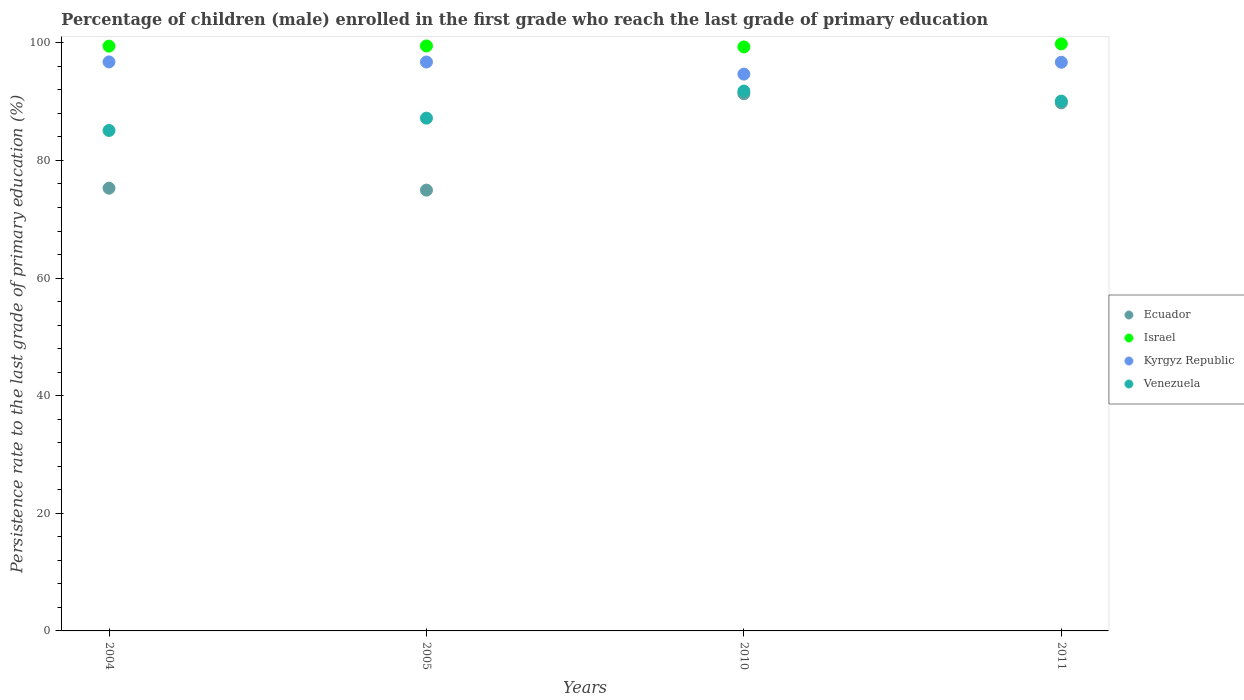How many different coloured dotlines are there?
Make the answer very short. 4. What is the persistence rate of children in Venezuela in 2010?
Give a very brief answer. 91.8. Across all years, what is the maximum persistence rate of children in Ecuador?
Provide a succinct answer. 91.34. Across all years, what is the minimum persistence rate of children in Ecuador?
Ensure brevity in your answer.  74.95. What is the total persistence rate of children in Venezuela in the graph?
Your answer should be very brief. 354.17. What is the difference between the persistence rate of children in Kyrgyz Republic in 2004 and that in 2011?
Your answer should be very brief. 0.06. What is the difference between the persistence rate of children in Israel in 2005 and the persistence rate of children in Kyrgyz Republic in 2010?
Your answer should be compact. 4.79. What is the average persistence rate of children in Israel per year?
Make the answer very short. 99.51. In the year 2011, what is the difference between the persistence rate of children in Ecuador and persistence rate of children in Israel?
Your answer should be compact. -10.03. In how many years, is the persistence rate of children in Ecuador greater than 64 %?
Your answer should be compact. 4. What is the ratio of the persistence rate of children in Kyrgyz Republic in 2005 to that in 2011?
Provide a succinct answer. 1. Is the persistence rate of children in Ecuador in 2004 less than that in 2011?
Keep it short and to the point. Yes. Is the difference between the persistence rate of children in Ecuador in 2004 and 2011 greater than the difference between the persistence rate of children in Israel in 2004 and 2011?
Provide a short and direct response. No. What is the difference between the highest and the second highest persistence rate of children in Venezuela?
Provide a short and direct response. 1.71. What is the difference between the highest and the lowest persistence rate of children in Venezuela?
Make the answer very short. 6.7. Is it the case that in every year, the sum of the persistence rate of children in Kyrgyz Republic and persistence rate of children in Israel  is greater than the persistence rate of children in Ecuador?
Your response must be concise. Yes. Does the persistence rate of children in Israel monotonically increase over the years?
Your response must be concise. No. Is the persistence rate of children in Israel strictly greater than the persistence rate of children in Kyrgyz Republic over the years?
Offer a very short reply. Yes. How many years are there in the graph?
Offer a terse response. 4. What is the difference between two consecutive major ticks on the Y-axis?
Ensure brevity in your answer.  20. Where does the legend appear in the graph?
Offer a terse response. Center right. How many legend labels are there?
Give a very brief answer. 4. How are the legend labels stacked?
Your response must be concise. Vertical. What is the title of the graph?
Make the answer very short. Percentage of children (male) enrolled in the first grade who reach the last grade of primary education. Does "Panama" appear as one of the legend labels in the graph?
Your response must be concise. No. What is the label or title of the Y-axis?
Your answer should be compact. Persistence rate to the last grade of primary education (%). What is the Persistence rate to the last grade of primary education (%) of Ecuador in 2004?
Offer a terse response. 75.28. What is the Persistence rate to the last grade of primary education (%) in Israel in 2004?
Offer a terse response. 99.44. What is the Persistence rate to the last grade of primary education (%) in Kyrgyz Republic in 2004?
Offer a very short reply. 96.75. What is the Persistence rate to the last grade of primary education (%) of Venezuela in 2004?
Make the answer very short. 85.1. What is the Persistence rate to the last grade of primary education (%) in Ecuador in 2005?
Ensure brevity in your answer.  74.95. What is the Persistence rate to the last grade of primary education (%) of Israel in 2005?
Your response must be concise. 99.47. What is the Persistence rate to the last grade of primary education (%) in Kyrgyz Republic in 2005?
Offer a very short reply. 96.74. What is the Persistence rate to the last grade of primary education (%) of Venezuela in 2005?
Ensure brevity in your answer.  87.19. What is the Persistence rate to the last grade of primary education (%) in Ecuador in 2010?
Offer a terse response. 91.34. What is the Persistence rate to the last grade of primary education (%) of Israel in 2010?
Provide a succinct answer. 99.3. What is the Persistence rate to the last grade of primary education (%) in Kyrgyz Republic in 2010?
Give a very brief answer. 94.68. What is the Persistence rate to the last grade of primary education (%) in Venezuela in 2010?
Ensure brevity in your answer.  91.8. What is the Persistence rate to the last grade of primary education (%) in Ecuador in 2011?
Your answer should be very brief. 89.79. What is the Persistence rate to the last grade of primary education (%) of Israel in 2011?
Give a very brief answer. 99.82. What is the Persistence rate to the last grade of primary education (%) of Kyrgyz Republic in 2011?
Give a very brief answer. 96.7. What is the Persistence rate to the last grade of primary education (%) of Venezuela in 2011?
Make the answer very short. 90.09. Across all years, what is the maximum Persistence rate to the last grade of primary education (%) of Ecuador?
Give a very brief answer. 91.34. Across all years, what is the maximum Persistence rate to the last grade of primary education (%) in Israel?
Your answer should be compact. 99.82. Across all years, what is the maximum Persistence rate to the last grade of primary education (%) in Kyrgyz Republic?
Make the answer very short. 96.75. Across all years, what is the maximum Persistence rate to the last grade of primary education (%) of Venezuela?
Your answer should be very brief. 91.8. Across all years, what is the minimum Persistence rate to the last grade of primary education (%) of Ecuador?
Your answer should be very brief. 74.95. Across all years, what is the minimum Persistence rate to the last grade of primary education (%) in Israel?
Offer a terse response. 99.3. Across all years, what is the minimum Persistence rate to the last grade of primary education (%) in Kyrgyz Republic?
Your answer should be compact. 94.68. Across all years, what is the minimum Persistence rate to the last grade of primary education (%) of Venezuela?
Your response must be concise. 85.1. What is the total Persistence rate to the last grade of primary education (%) of Ecuador in the graph?
Give a very brief answer. 331.36. What is the total Persistence rate to the last grade of primary education (%) of Israel in the graph?
Ensure brevity in your answer.  398.02. What is the total Persistence rate to the last grade of primary education (%) of Kyrgyz Republic in the graph?
Your answer should be very brief. 384.87. What is the total Persistence rate to the last grade of primary education (%) of Venezuela in the graph?
Your answer should be very brief. 354.17. What is the difference between the Persistence rate to the last grade of primary education (%) of Ecuador in 2004 and that in 2005?
Offer a very short reply. 0.33. What is the difference between the Persistence rate to the last grade of primary education (%) in Israel in 2004 and that in 2005?
Give a very brief answer. -0.03. What is the difference between the Persistence rate to the last grade of primary education (%) in Kyrgyz Republic in 2004 and that in 2005?
Give a very brief answer. 0.02. What is the difference between the Persistence rate to the last grade of primary education (%) of Venezuela in 2004 and that in 2005?
Provide a short and direct response. -2.1. What is the difference between the Persistence rate to the last grade of primary education (%) of Ecuador in 2004 and that in 2010?
Your answer should be very brief. -16.06. What is the difference between the Persistence rate to the last grade of primary education (%) in Israel in 2004 and that in 2010?
Provide a succinct answer. 0.14. What is the difference between the Persistence rate to the last grade of primary education (%) of Kyrgyz Republic in 2004 and that in 2010?
Offer a terse response. 2.07. What is the difference between the Persistence rate to the last grade of primary education (%) in Venezuela in 2004 and that in 2010?
Provide a short and direct response. -6.7. What is the difference between the Persistence rate to the last grade of primary education (%) in Ecuador in 2004 and that in 2011?
Provide a short and direct response. -14.51. What is the difference between the Persistence rate to the last grade of primary education (%) of Israel in 2004 and that in 2011?
Offer a very short reply. -0.38. What is the difference between the Persistence rate to the last grade of primary education (%) in Kyrgyz Republic in 2004 and that in 2011?
Make the answer very short. 0.06. What is the difference between the Persistence rate to the last grade of primary education (%) in Venezuela in 2004 and that in 2011?
Give a very brief answer. -4.99. What is the difference between the Persistence rate to the last grade of primary education (%) in Ecuador in 2005 and that in 2010?
Give a very brief answer. -16.39. What is the difference between the Persistence rate to the last grade of primary education (%) in Israel in 2005 and that in 2010?
Offer a very short reply. 0.17. What is the difference between the Persistence rate to the last grade of primary education (%) in Kyrgyz Republic in 2005 and that in 2010?
Provide a short and direct response. 2.06. What is the difference between the Persistence rate to the last grade of primary education (%) in Venezuela in 2005 and that in 2010?
Ensure brevity in your answer.  -4.6. What is the difference between the Persistence rate to the last grade of primary education (%) in Ecuador in 2005 and that in 2011?
Provide a succinct answer. -14.84. What is the difference between the Persistence rate to the last grade of primary education (%) of Israel in 2005 and that in 2011?
Provide a short and direct response. -0.35. What is the difference between the Persistence rate to the last grade of primary education (%) in Kyrgyz Republic in 2005 and that in 2011?
Make the answer very short. 0.04. What is the difference between the Persistence rate to the last grade of primary education (%) of Venezuela in 2005 and that in 2011?
Keep it short and to the point. -2.9. What is the difference between the Persistence rate to the last grade of primary education (%) of Ecuador in 2010 and that in 2011?
Provide a short and direct response. 1.55. What is the difference between the Persistence rate to the last grade of primary education (%) of Israel in 2010 and that in 2011?
Provide a succinct answer. -0.52. What is the difference between the Persistence rate to the last grade of primary education (%) of Kyrgyz Republic in 2010 and that in 2011?
Give a very brief answer. -2.02. What is the difference between the Persistence rate to the last grade of primary education (%) in Venezuela in 2010 and that in 2011?
Offer a terse response. 1.71. What is the difference between the Persistence rate to the last grade of primary education (%) in Ecuador in 2004 and the Persistence rate to the last grade of primary education (%) in Israel in 2005?
Provide a succinct answer. -24.19. What is the difference between the Persistence rate to the last grade of primary education (%) of Ecuador in 2004 and the Persistence rate to the last grade of primary education (%) of Kyrgyz Republic in 2005?
Keep it short and to the point. -21.46. What is the difference between the Persistence rate to the last grade of primary education (%) in Ecuador in 2004 and the Persistence rate to the last grade of primary education (%) in Venezuela in 2005?
Provide a succinct answer. -11.91. What is the difference between the Persistence rate to the last grade of primary education (%) of Israel in 2004 and the Persistence rate to the last grade of primary education (%) of Kyrgyz Republic in 2005?
Your answer should be compact. 2.7. What is the difference between the Persistence rate to the last grade of primary education (%) in Israel in 2004 and the Persistence rate to the last grade of primary education (%) in Venezuela in 2005?
Your response must be concise. 12.24. What is the difference between the Persistence rate to the last grade of primary education (%) in Kyrgyz Republic in 2004 and the Persistence rate to the last grade of primary education (%) in Venezuela in 2005?
Your answer should be compact. 9.56. What is the difference between the Persistence rate to the last grade of primary education (%) of Ecuador in 2004 and the Persistence rate to the last grade of primary education (%) of Israel in 2010?
Your response must be concise. -24.02. What is the difference between the Persistence rate to the last grade of primary education (%) in Ecuador in 2004 and the Persistence rate to the last grade of primary education (%) in Kyrgyz Republic in 2010?
Make the answer very short. -19.4. What is the difference between the Persistence rate to the last grade of primary education (%) of Ecuador in 2004 and the Persistence rate to the last grade of primary education (%) of Venezuela in 2010?
Your answer should be very brief. -16.52. What is the difference between the Persistence rate to the last grade of primary education (%) of Israel in 2004 and the Persistence rate to the last grade of primary education (%) of Kyrgyz Republic in 2010?
Keep it short and to the point. 4.76. What is the difference between the Persistence rate to the last grade of primary education (%) of Israel in 2004 and the Persistence rate to the last grade of primary education (%) of Venezuela in 2010?
Ensure brevity in your answer.  7.64. What is the difference between the Persistence rate to the last grade of primary education (%) in Kyrgyz Republic in 2004 and the Persistence rate to the last grade of primary education (%) in Venezuela in 2010?
Provide a succinct answer. 4.96. What is the difference between the Persistence rate to the last grade of primary education (%) in Ecuador in 2004 and the Persistence rate to the last grade of primary education (%) in Israel in 2011?
Keep it short and to the point. -24.54. What is the difference between the Persistence rate to the last grade of primary education (%) in Ecuador in 2004 and the Persistence rate to the last grade of primary education (%) in Kyrgyz Republic in 2011?
Keep it short and to the point. -21.42. What is the difference between the Persistence rate to the last grade of primary education (%) in Ecuador in 2004 and the Persistence rate to the last grade of primary education (%) in Venezuela in 2011?
Offer a terse response. -14.81. What is the difference between the Persistence rate to the last grade of primary education (%) in Israel in 2004 and the Persistence rate to the last grade of primary education (%) in Kyrgyz Republic in 2011?
Offer a terse response. 2.74. What is the difference between the Persistence rate to the last grade of primary education (%) in Israel in 2004 and the Persistence rate to the last grade of primary education (%) in Venezuela in 2011?
Provide a short and direct response. 9.35. What is the difference between the Persistence rate to the last grade of primary education (%) of Kyrgyz Republic in 2004 and the Persistence rate to the last grade of primary education (%) of Venezuela in 2011?
Provide a short and direct response. 6.67. What is the difference between the Persistence rate to the last grade of primary education (%) in Ecuador in 2005 and the Persistence rate to the last grade of primary education (%) in Israel in 2010?
Your answer should be very brief. -24.35. What is the difference between the Persistence rate to the last grade of primary education (%) of Ecuador in 2005 and the Persistence rate to the last grade of primary education (%) of Kyrgyz Republic in 2010?
Ensure brevity in your answer.  -19.73. What is the difference between the Persistence rate to the last grade of primary education (%) in Ecuador in 2005 and the Persistence rate to the last grade of primary education (%) in Venezuela in 2010?
Your answer should be very brief. -16.84. What is the difference between the Persistence rate to the last grade of primary education (%) in Israel in 2005 and the Persistence rate to the last grade of primary education (%) in Kyrgyz Republic in 2010?
Ensure brevity in your answer.  4.79. What is the difference between the Persistence rate to the last grade of primary education (%) of Israel in 2005 and the Persistence rate to the last grade of primary education (%) of Venezuela in 2010?
Provide a succinct answer. 7.67. What is the difference between the Persistence rate to the last grade of primary education (%) in Kyrgyz Republic in 2005 and the Persistence rate to the last grade of primary education (%) in Venezuela in 2010?
Offer a very short reply. 4.94. What is the difference between the Persistence rate to the last grade of primary education (%) in Ecuador in 2005 and the Persistence rate to the last grade of primary education (%) in Israel in 2011?
Provide a short and direct response. -24.87. What is the difference between the Persistence rate to the last grade of primary education (%) in Ecuador in 2005 and the Persistence rate to the last grade of primary education (%) in Kyrgyz Republic in 2011?
Offer a terse response. -21.74. What is the difference between the Persistence rate to the last grade of primary education (%) of Ecuador in 2005 and the Persistence rate to the last grade of primary education (%) of Venezuela in 2011?
Keep it short and to the point. -15.14. What is the difference between the Persistence rate to the last grade of primary education (%) in Israel in 2005 and the Persistence rate to the last grade of primary education (%) in Kyrgyz Republic in 2011?
Offer a terse response. 2.77. What is the difference between the Persistence rate to the last grade of primary education (%) of Israel in 2005 and the Persistence rate to the last grade of primary education (%) of Venezuela in 2011?
Provide a succinct answer. 9.38. What is the difference between the Persistence rate to the last grade of primary education (%) in Kyrgyz Republic in 2005 and the Persistence rate to the last grade of primary education (%) in Venezuela in 2011?
Provide a succinct answer. 6.65. What is the difference between the Persistence rate to the last grade of primary education (%) in Ecuador in 2010 and the Persistence rate to the last grade of primary education (%) in Israel in 2011?
Provide a succinct answer. -8.48. What is the difference between the Persistence rate to the last grade of primary education (%) in Ecuador in 2010 and the Persistence rate to the last grade of primary education (%) in Kyrgyz Republic in 2011?
Your answer should be compact. -5.36. What is the difference between the Persistence rate to the last grade of primary education (%) of Ecuador in 2010 and the Persistence rate to the last grade of primary education (%) of Venezuela in 2011?
Offer a very short reply. 1.25. What is the difference between the Persistence rate to the last grade of primary education (%) of Israel in 2010 and the Persistence rate to the last grade of primary education (%) of Kyrgyz Republic in 2011?
Give a very brief answer. 2.61. What is the difference between the Persistence rate to the last grade of primary education (%) in Israel in 2010 and the Persistence rate to the last grade of primary education (%) in Venezuela in 2011?
Your response must be concise. 9.21. What is the difference between the Persistence rate to the last grade of primary education (%) of Kyrgyz Republic in 2010 and the Persistence rate to the last grade of primary education (%) of Venezuela in 2011?
Keep it short and to the point. 4.59. What is the average Persistence rate to the last grade of primary education (%) in Ecuador per year?
Your answer should be very brief. 82.84. What is the average Persistence rate to the last grade of primary education (%) of Israel per year?
Provide a succinct answer. 99.51. What is the average Persistence rate to the last grade of primary education (%) in Kyrgyz Republic per year?
Your answer should be very brief. 96.22. What is the average Persistence rate to the last grade of primary education (%) of Venezuela per year?
Your answer should be compact. 88.54. In the year 2004, what is the difference between the Persistence rate to the last grade of primary education (%) in Ecuador and Persistence rate to the last grade of primary education (%) in Israel?
Give a very brief answer. -24.16. In the year 2004, what is the difference between the Persistence rate to the last grade of primary education (%) of Ecuador and Persistence rate to the last grade of primary education (%) of Kyrgyz Republic?
Your response must be concise. -21.48. In the year 2004, what is the difference between the Persistence rate to the last grade of primary education (%) in Ecuador and Persistence rate to the last grade of primary education (%) in Venezuela?
Offer a terse response. -9.82. In the year 2004, what is the difference between the Persistence rate to the last grade of primary education (%) of Israel and Persistence rate to the last grade of primary education (%) of Kyrgyz Republic?
Ensure brevity in your answer.  2.68. In the year 2004, what is the difference between the Persistence rate to the last grade of primary education (%) in Israel and Persistence rate to the last grade of primary education (%) in Venezuela?
Your answer should be very brief. 14.34. In the year 2004, what is the difference between the Persistence rate to the last grade of primary education (%) of Kyrgyz Republic and Persistence rate to the last grade of primary education (%) of Venezuela?
Your answer should be very brief. 11.66. In the year 2005, what is the difference between the Persistence rate to the last grade of primary education (%) of Ecuador and Persistence rate to the last grade of primary education (%) of Israel?
Offer a terse response. -24.52. In the year 2005, what is the difference between the Persistence rate to the last grade of primary education (%) of Ecuador and Persistence rate to the last grade of primary education (%) of Kyrgyz Republic?
Provide a short and direct response. -21.78. In the year 2005, what is the difference between the Persistence rate to the last grade of primary education (%) in Ecuador and Persistence rate to the last grade of primary education (%) in Venezuela?
Make the answer very short. -12.24. In the year 2005, what is the difference between the Persistence rate to the last grade of primary education (%) of Israel and Persistence rate to the last grade of primary education (%) of Kyrgyz Republic?
Give a very brief answer. 2.73. In the year 2005, what is the difference between the Persistence rate to the last grade of primary education (%) of Israel and Persistence rate to the last grade of primary education (%) of Venezuela?
Offer a very short reply. 12.28. In the year 2005, what is the difference between the Persistence rate to the last grade of primary education (%) in Kyrgyz Republic and Persistence rate to the last grade of primary education (%) in Venezuela?
Offer a terse response. 9.55. In the year 2010, what is the difference between the Persistence rate to the last grade of primary education (%) of Ecuador and Persistence rate to the last grade of primary education (%) of Israel?
Offer a terse response. -7.96. In the year 2010, what is the difference between the Persistence rate to the last grade of primary education (%) of Ecuador and Persistence rate to the last grade of primary education (%) of Kyrgyz Republic?
Your answer should be very brief. -3.34. In the year 2010, what is the difference between the Persistence rate to the last grade of primary education (%) of Ecuador and Persistence rate to the last grade of primary education (%) of Venezuela?
Offer a very short reply. -0.46. In the year 2010, what is the difference between the Persistence rate to the last grade of primary education (%) of Israel and Persistence rate to the last grade of primary education (%) of Kyrgyz Republic?
Your response must be concise. 4.62. In the year 2010, what is the difference between the Persistence rate to the last grade of primary education (%) of Israel and Persistence rate to the last grade of primary education (%) of Venezuela?
Give a very brief answer. 7.5. In the year 2010, what is the difference between the Persistence rate to the last grade of primary education (%) of Kyrgyz Republic and Persistence rate to the last grade of primary education (%) of Venezuela?
Make the answer very short. 2.88. In the year 2011, what is the difference between the Persistence rate to the last grade of primary education (%) of Ecuador and Persistence rate to the last grade of primary education (%) of Israel?
Ensure brevity in your answer.  -10.03. In the year 2011, what is the difference between the Persistence rate to the last grade of primary education (%) of Ecuador and Persistence rate to the last grade of primary education (%) of Kyrgyz Republic?
Ensure brevity in your answer.  -6.91. In the year 2011, what is the difference between the Persistence rate to the last grade of primary education (%) of Ecuador and Persistence rate to the last grade of primary education (%) of Venezuela?
Provide a succinct answer. -0.3. In the year 2011, what is the difference between the Persistence rate to the last grade of primary education (%) in Israel and Persistence rate to the last grade of primary education (%) in Kyrgyz Republic?
Offer a very short reply. 3.12. In the year 2011, what is the difference between the Persistence rate to the last grade of primary education (%) in Israel and Persistence rate to the last grade of primary education (%) in Venezuela?
Give a very brief answer. 9.73. In the year 2011, what is the difference between the Persistence rate to the last grade of primary education (%) in Kyrgyz Republic and Persistence rate to the last grade of primary education (%) in Venezuela?
Ensure brevity in your answer.  6.61. What is the ratio of the Persistence rate to the last grade of primary education (%) in Ecuador in 2004 to that in 2005?
Make the answer very short. 1. What is the ratio of the Persistence rate to the last grade of primary education (%) of Israel in 2004 to that in 2005?
Offer a terse response. 1. What is the ratio of the Persistence rate to the last grade of primary education (%) of Venezuela in 2004 to that in 2005?
Make the answer very short. 0.98. What is the ratio of the Persistence rate to the last grade of primary education (%) in Ecuador in 2004 to that in 2010?
Your answer should be compact. 0.82. What is the ratio of the Persistence rate to the last grade of primary education (%) in Kyrgyz Republic in 2004 to that in 2010?
Make the answer very short. 1.02. What is the ratio of the Persistence rate to the last grade of primary education (%) in Venezuela in 2004 to that in 2010?
Your response must be concise. 0.93. What is the ratio of the Persistence rate to the last grade of primary education (%) in Ecuador in 2004 to that in 2011?
Offer a terse response. 0.84. What is the ratio of the Persistence rate to the last grade of primary education (%) in Israel in 2004 to that in 2011?
Your answer should be very brief. 1. What is the ratio of the Persistence rate to the last grade of primary education (%) of Kyrgyz Republic in 2004 to that in 2011?
Keep it short and to the point. 1. What is the ratio of the Persistence rate to the last grade of primary education (%) in Venezuela in 2004 to that in 2011?
Your response must be concise. 0.94. What is the ratio of the Persistence rate to the last grade of primary education (%) of Ecuador in 2005 to that in 2010?
Provide a succinct answer. 0.82. What is the ratio of the Persistence rate to the last grade of primary education (%) of Kyrgyz Republic in 2005 to that in 2010?
Offer a terse response. 1.02. What is the ratio of the Persistence rate to the last grade of primary education (%) of Venezuela in 2005 to that in 2010?
Your answer should be compact. 0.95. What is the ratio of the Persistence rate to the last grade of primary education (%) in Ecuador in 2005 to that in 2011?
Give a very brief answer. 0.83. What is the ratio of the Persistence rate to the last grade of primary education (%) in Kyrgyz Republic in 2005 to that in 2011?
Give a very brief answer. 1. What is the ratio of the Persistence rate to the last grade of primary education (%) of Venezuela in 2005 to that in 2011?
Give a very brief answer. 0.97. What is the ratio of the Persistence rate to the last grade of primary education (%) in Ecuador in 2010 to that in 2011?
Your response must be concise. 1.02. What is the ratio of the Persistence rate to the last grade of primary education (%) of Kyrgyz Republic in 2010 to that in 2011?
Your response must be concise. 0.98. What is the difference between the highest and the second highest Persistence rate to the last grade of primary education (%) in Ecuador?
Make the answer very short. 1.55. What is the difference between the highest and the second highest Persistence rate to the last grade of primary education (%) in Israel?
Your answer should be very brief. 0.35. What is the difference between the highest and the second highest Persistence rate to the last grade of primary education (%) of Kyrgyz Republic?
Make the answer very short. 0.02. What is the difference between the highest and the second highest Persistence rate to the last grade of primary education (%) of Venezuela?
Your response must be concise. 1.71. What is the difference between the highest and the lowest Persistence rate to the last grade of primary education (%) in Ecuador?
Offer a very short reply. 16.39. What is the difference between the highest and the lowest Persistence rate to the last grade of primary education (%) of Israel?
Offer a very short reply. 0.52. What is the difference between the highest and the lowest Persistence rate to the last grade of primary education (%) in Kyrgyz Republic?
Offer a terse response. 2.07. What is the difference between the highest and the lowest Persistence rate to the last grade of primary education (%) in Venezuela?
Your response must be concise. 6.7. 